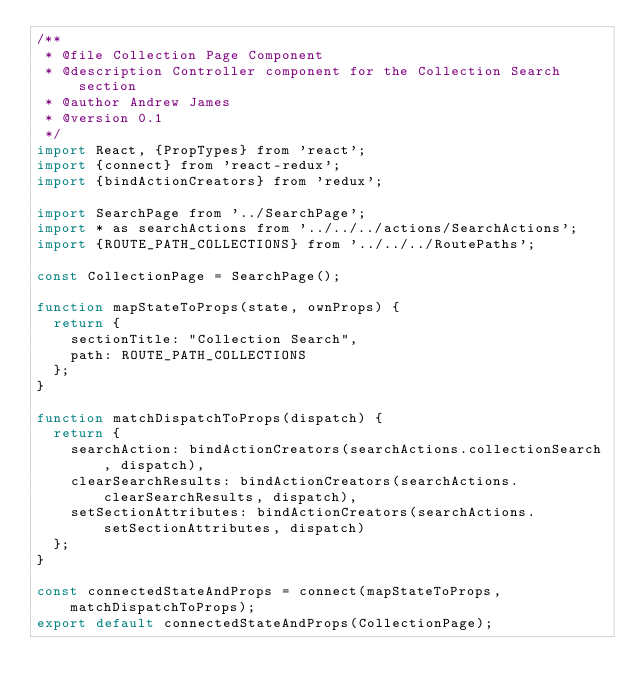<code> <loc_0><loc_0><loc_500><loc_500><_JavaScript_>/**
 * @file Collection Page Component
 * @description Controller component for the Collection Search section
 * @author Andrew James
 * @version 0.1
 */
import React, {PropTypes} from 'react';
import {connect} from 'react-redux';
import {bindActionCreators} from 'redux';

import SearchPage from '../SearchPage';
import * as searchActions from '../../../actions/SearchActions';
import {ROUTE_PATH_COLLECTIONS} from '../../../RoutePaths';

const CollectionPage = SearchPage();

function mapStateToProps(state, ownProps) {
  return {
    sectionTitle: "Collection Search",
    path: ROUTE_PATH_COLLECTIONS
  };
}

function matchDispatchToProps(dispatch) {
  return {
    searchAction: bindActionCreators(searchActions.collectionSearch, dispatch),
    clearSearchResults: bindActionCreators(searchActions.clearSearchResults, dispatch),
    setSectionAttributes: bindActionCreators(searchActions.setSectionAttributes, dispatch)
  };
}

const connectedStateAndProps = connect(mapStateToProps, matchDispatchToProps);
export default connectedStateAndProps(CollectionPage);
</code> 